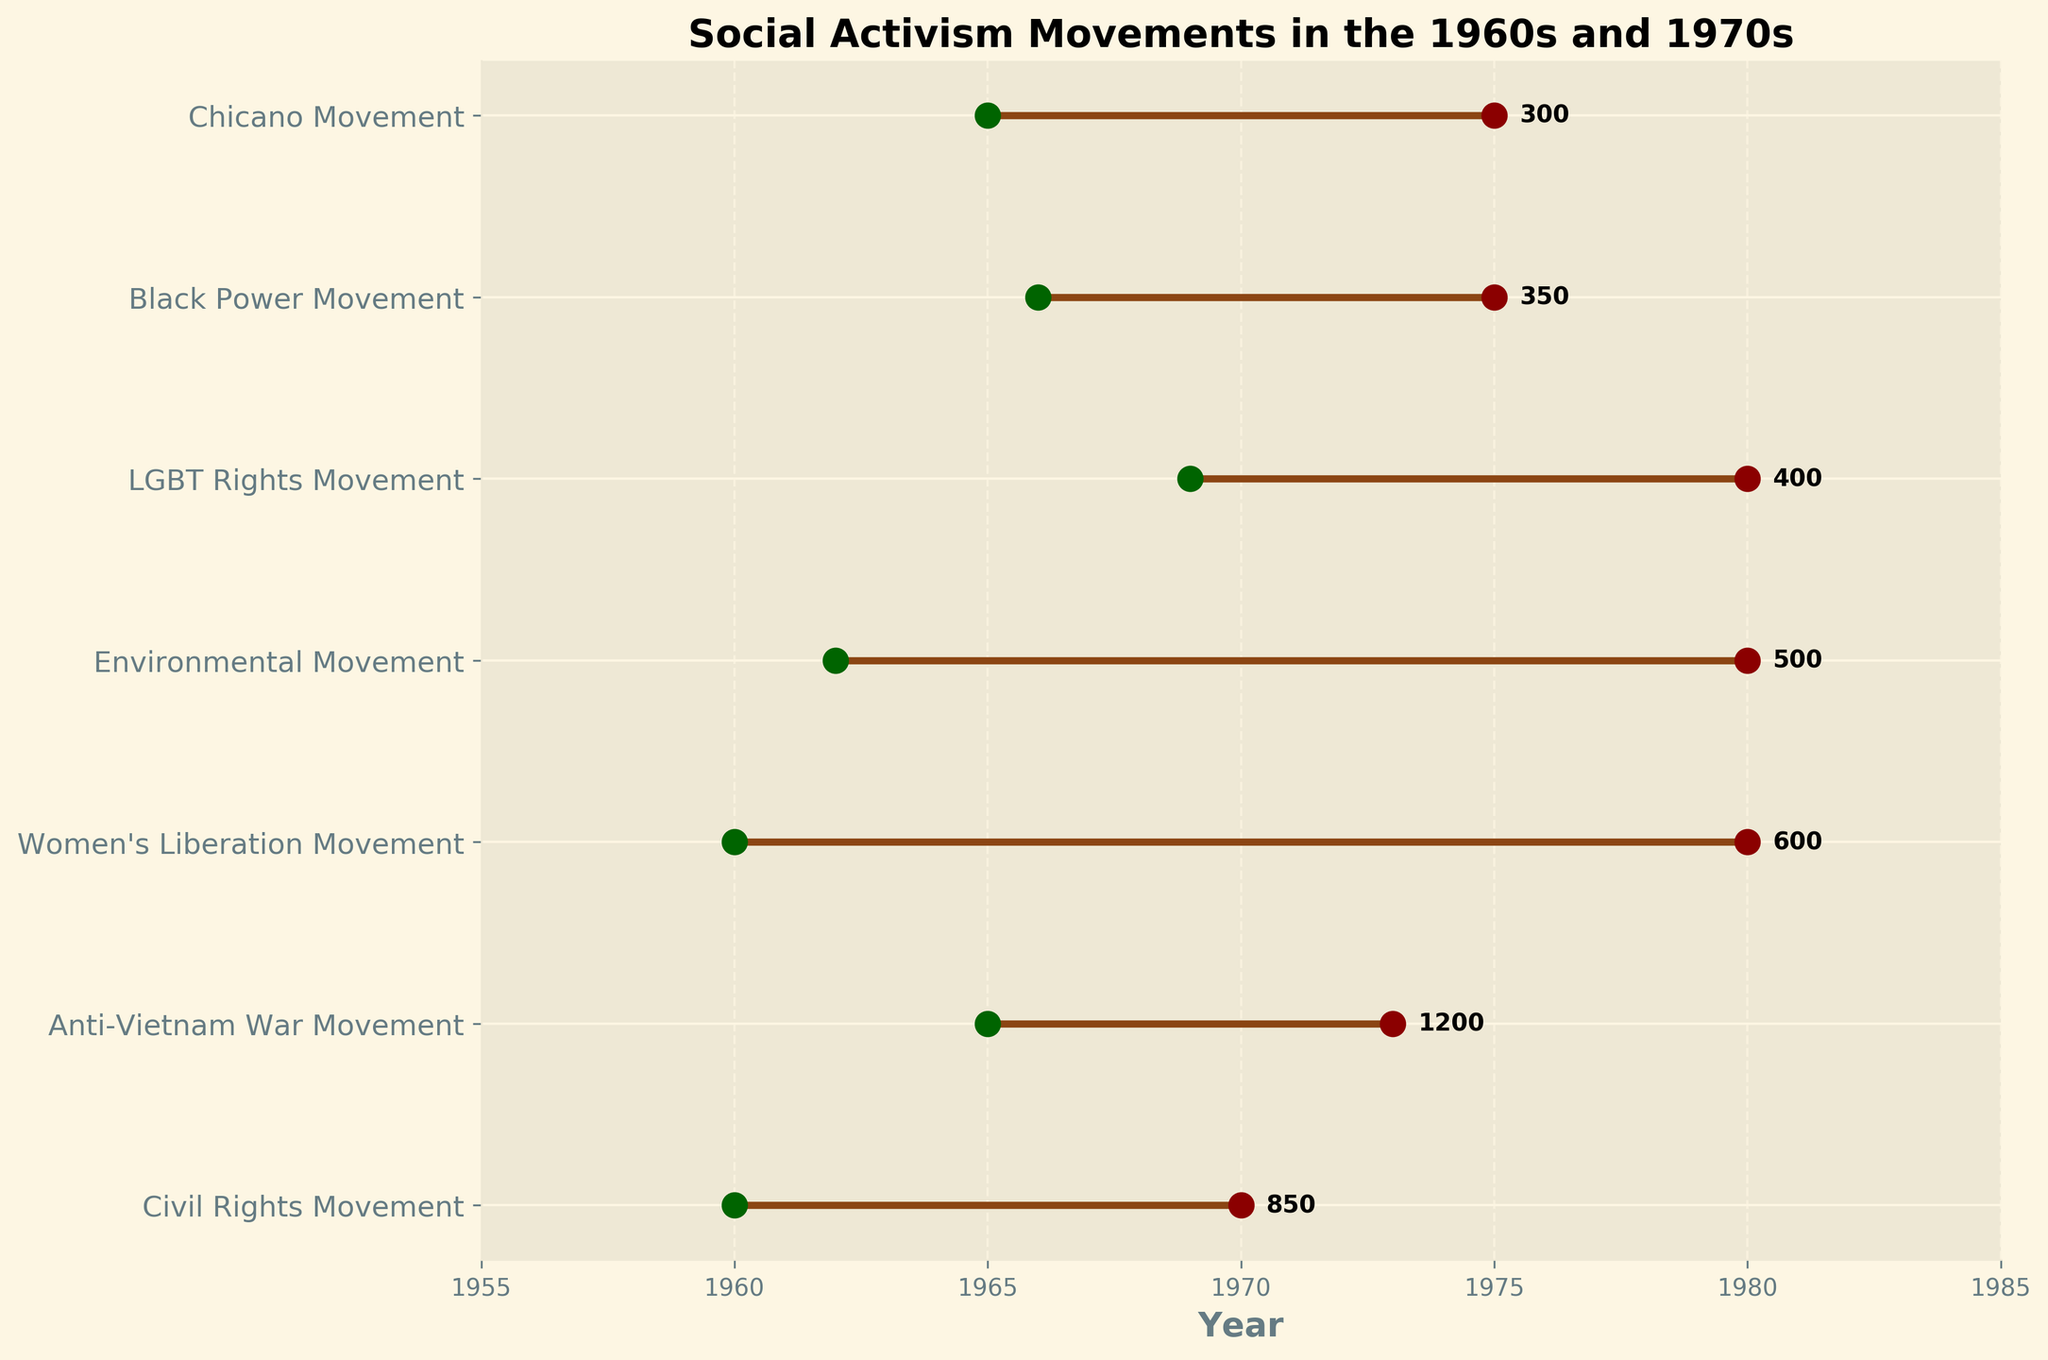What is the title of the figure? The title is usually located at the top of the figure, and it describes the content of the plot.
Answer: Social Activism Movements in the 1960s and 1970s How many protests were held by the Civil Rights Movement? Look for the Civil Rights Movement on the y-axis, then check the number next to its end year.
Answer: 850 Between which years did the Anti-Vietnam War Movement occur? Find the Anti-Vietnam War Movement on the y-axis, then refer to the starting and ending points of its line.
Answer: 1965-1973 Which Social Activism Movement had the fewest protests? Compare the numbers of protests for each movement listed next to their end years.
Answer: Chicano Movement Which movement had protests starting the latest? Identify the movement with the highest start year by comparing the starting points of all lines.
Answer: LGBT Rights Movement How many total protests were held by the Environmental Movement and the Black Power Movement? Add the number of protests of both movements. Environmental Movement (500) + Black Power Movement (350).
Answer: 850 What is the difference in the number of protests between the Women’s Liberation Movement and the Civil Rights Movement? Subtract the number of protests of the Civil Rights Movement from the Women’s Liberation Movement.
Answer: 250 (850 - 600) Which movements lasted for more than 15 years? Compare the difference between the start and end years for each movement, selecting those with a difference greater than 15.
Answer: Women's Liberation Movement, Environmental Movement Which movements cover the same time period from 1965 to 1975? Identify movements with start years of 1965 and end years of 1975.
Answer: Anti-Vietnam War Movement, Black Power Movement, Chicano Movement Did the number of protests increase or decrease from the Civil Rights Movement to the Anti-Vietnam War Movement? Compare the number of protests for both movements: Civil Rights Movement (850) and Anti-Vietnam War Movement (1200).
Answer: Increase 